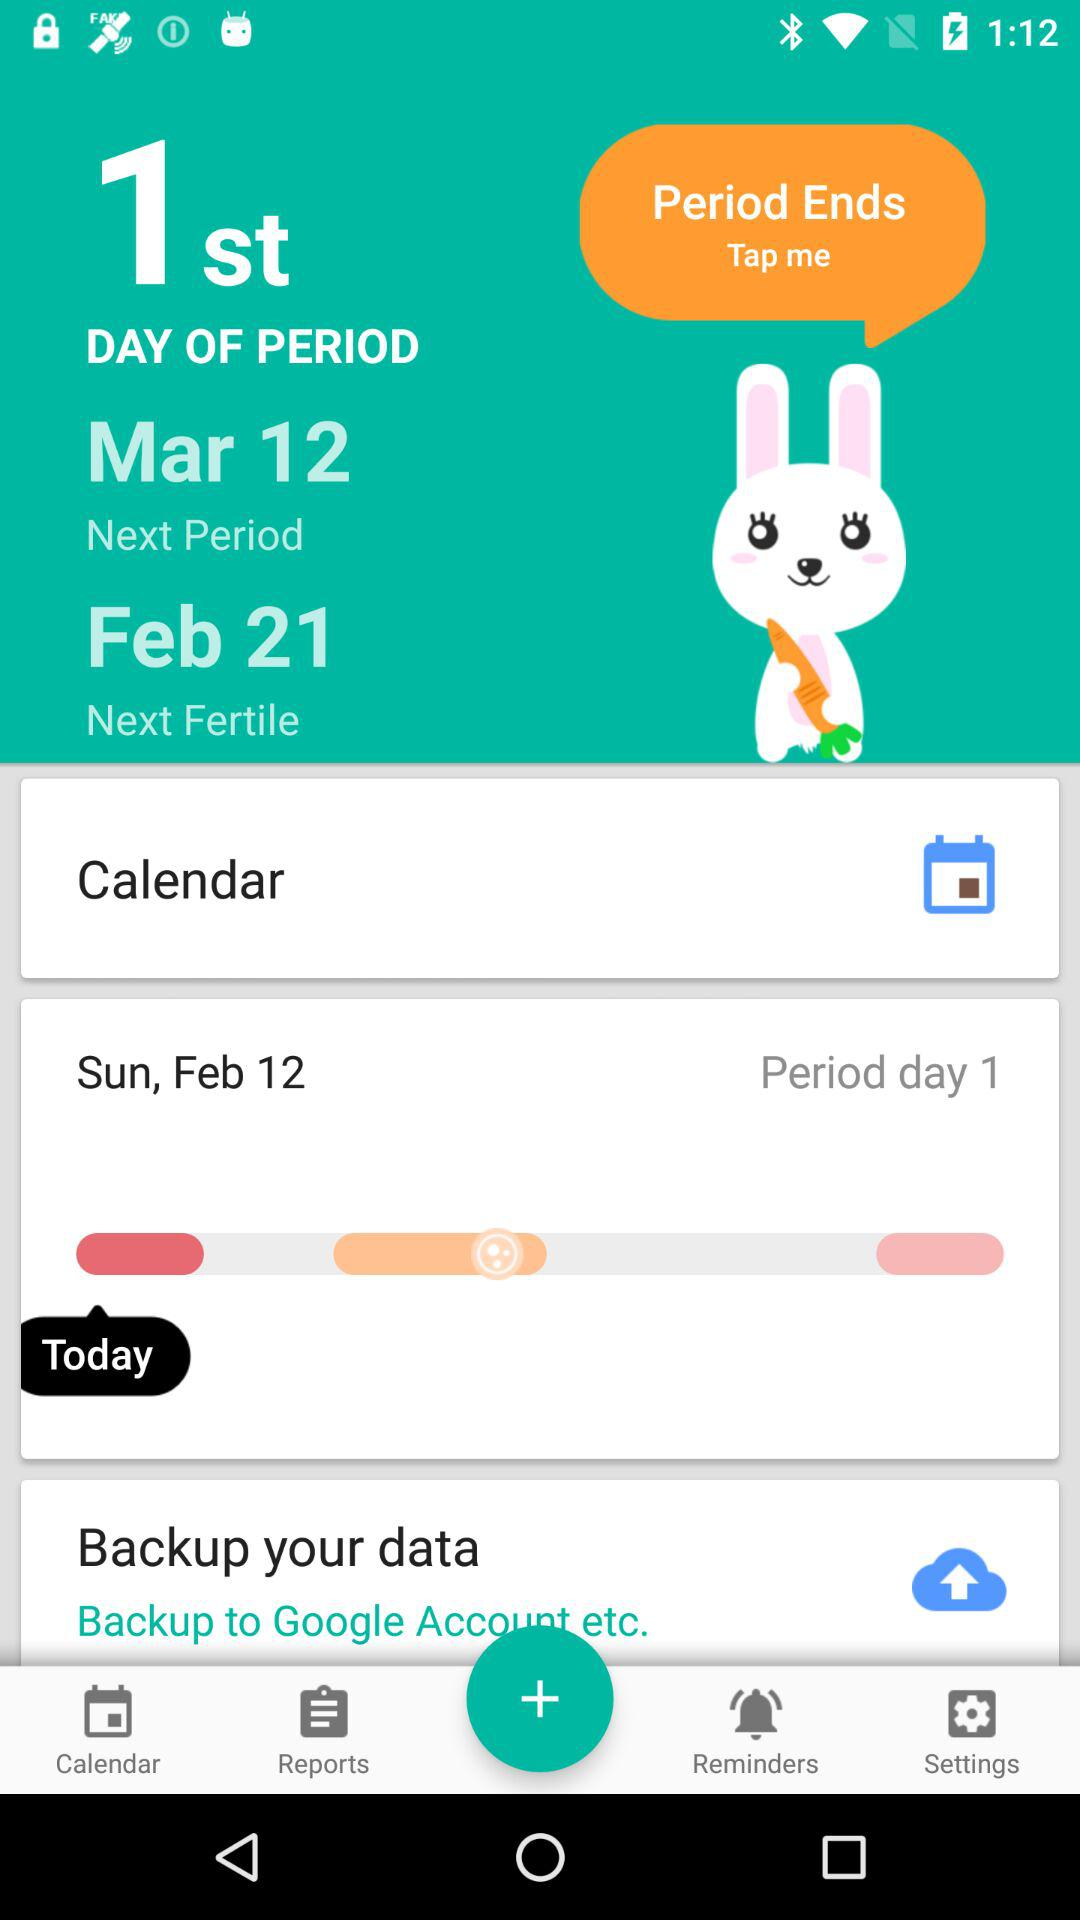Which day of the period is it? It is the 1st day of the period. 